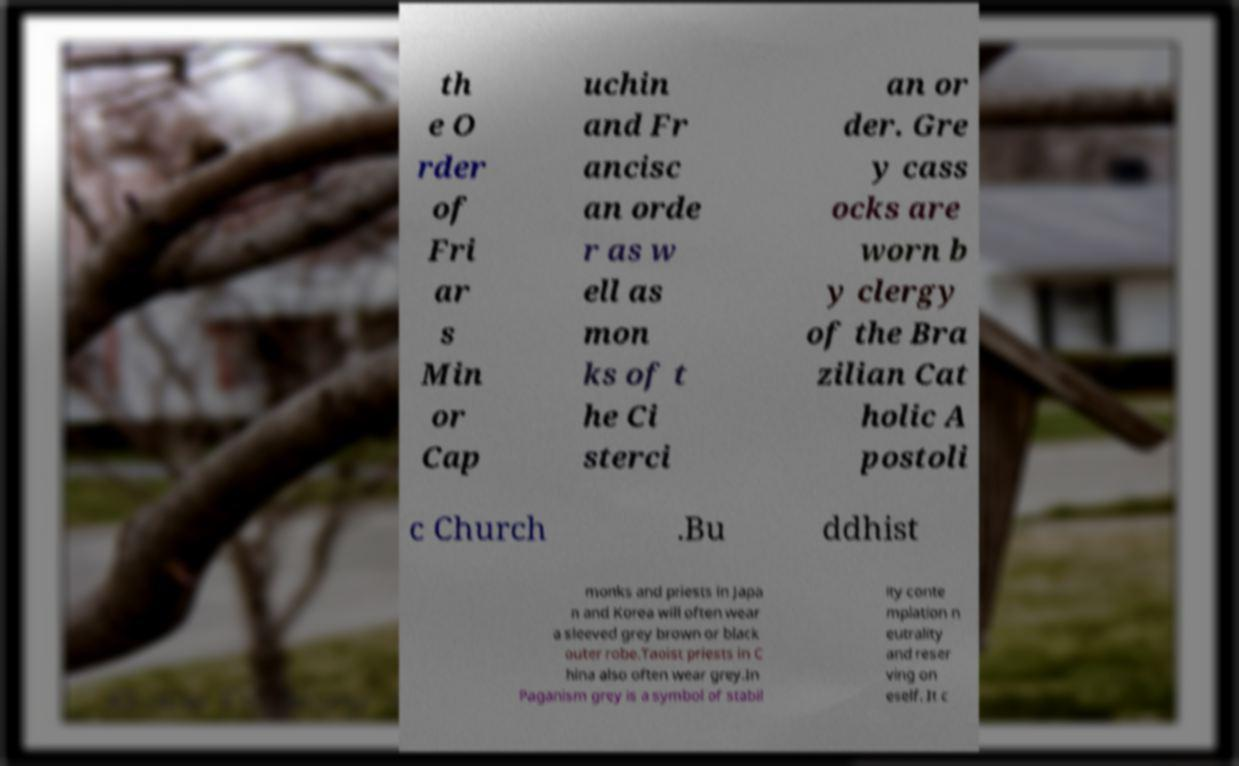Please read and relay the text visible in this image. What does it say? th e O rder of Fri ar s Min or Cap uchin and Fr ancisc an orde r as w ell as mon ks of t he Ci sterci an or der. Gre y cass ocks are worn b y clergy of the Bra zilian Cat holic A postoli c Church .Bu ddhist monks and priests in Japa n and Korea will often wear a sleeved grey brown or black outer robe.Taoist priests in C hina also often wear grey.In Paganism grey is a symbol of stabil ity conte mplation n eutrality and reser ving on eself. It c 